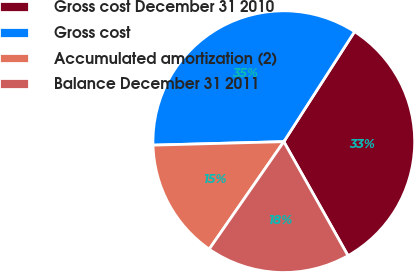<chart> <loc_0><loc_0><loc_500><loc_500><pie_chart><fcel>Gross cost December 31 2010<fcel>Gross cost<fcel>Accumulated amortization (2)<fcel>Balance December 31 2011<nl><fcel>32.74%<fcel>34.52%<fcel>14.92%<fcel>17.82%<nl></chart> 